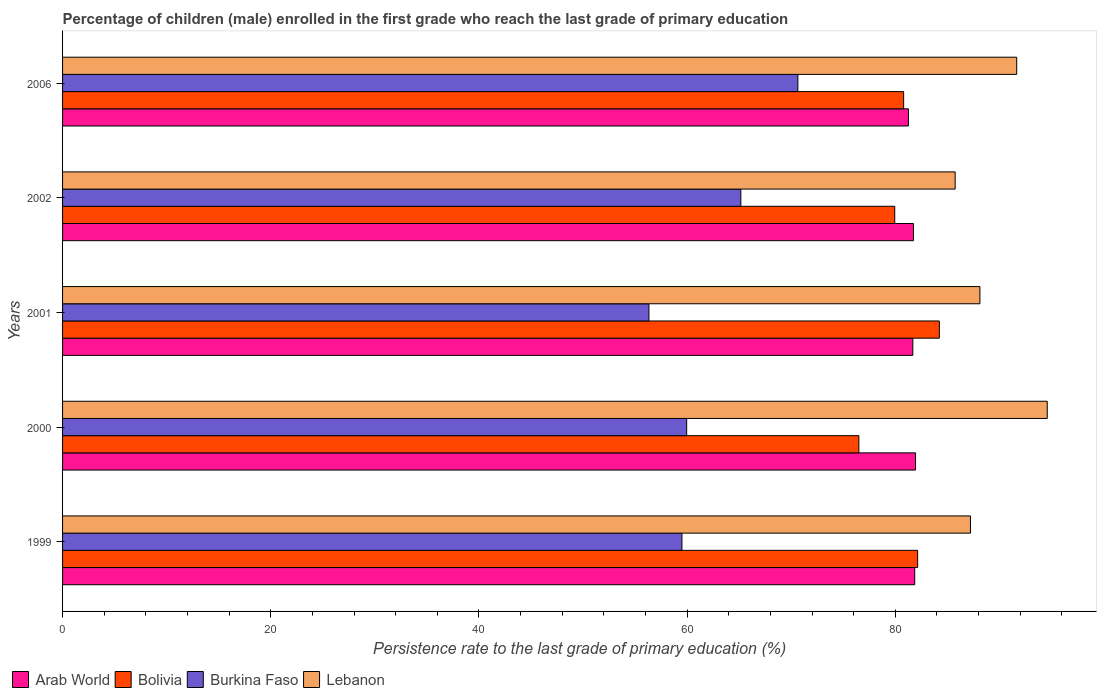Are the number of bars on each tick of the Y-axis equal?
Make the answer very short. Yes. How many bars are there on the 3rd tick from the bottom?
Provide a short and direct response. 4. What is the label of the 5th group of bars from the top?
Keep it short and to the point. 1999. What is the persistence rate of children in Burkina Faso in 2000?
Your answer should be very brief. 59.96. Across all years, what is the maximum persistence rate of children in Burkina Faso?
Your answer should be compact. 70.64. Across all years, what is the minimum persistence rate of children in Lebanon?
Your answer should be compact. 85.75. What is the total persistence rate of children in Burkina Faso in the graph?
Ensure brevity in your answer.  311.6. What is the difference between the persistence rate of children in Lebanon in 1999 and that in 2001?
Your answer should be compact. -0.91. What is the difference between the persistence rate of children in Lebanon in 2006 and the persistence rate of children in Arab World in 2002?
Provide a short and direct response. 9.92. What is the average persistence rate of children in Lebanon per year?
Keep it short and to the point. 89.47. In the year 2002, what is the difference between the persistence rate of children in Bolivia and persistence rate of children in Burkina Faso?
Your answer should be compact. 14.78. In how many years, is the persistence rate of children in Lebanon greater than 64 %?
Make the answer very short. 5. What is the ratio of the persistence rate of children in Arab World in 2001 to that in 2002?
Give a very brief answer. 1. What is the difference between the highest and the second highest persistence rate of children in Lebanon?
Provide a succinct answer. 2.94. What is the difference between the highest and the lowest persistence rate of children in Burkina Faso?
Provide a succinct answer. 14.31. Is it the case that in every year, the sum of the persistence rate of children in Burkina Faso and persistence rate of children in Arab World is greater than the sum of persistence rate of children in Bolivia and persistence rate of children in Lebanon?
Provide a succinct answer. Yes. What does the 2nd bar from the top in 2001 represents?
Offer a very short reply. Burkina Faso. What does the 3rd bar from the bottom in 2006 represents?
Give a very brief answer. Burkina Faso. How many bars are there?
Provide a succinct answer. 20. Are all the bars in the graph horizontal?
Ensure brevity in your answer.  Yes. Does the graph contain grids?
Offer a terse response. No. How many legend labels are there?
Offer a very short reply. 4. How are the legend labels stacked?
Make the answer very short. Horizontal. What is the title of the graph?
Your answer should be very brief. Percentage of children (male) enrolled in the first grade who reach the last grade of primary education. What is the label or title of the X-axis?
Provide a short and direct response. Persistence rate to the last grade of primary education (%). What is the label or title of the Y-axis?
Your answer should be very brief. Years. What is the Persistence rate to the last grade of primary education (%) in Arab World in 1999?
Provide a short and direct response. 81.87. What is the Persistence rate to the last grade of primary education (%) in Bolivia in 1999?
Provide a short and direct response. 82.15. What is the Persistence rate to the last grade of primary education (%) in Burkina Faso in 1999?
Give a very brief answer. 59.5. What is the Persistence rate to the last grade of primary education (%) of Lebanon in 1999?
Your answer should be compact. 87.22. What is the Persistence rate to the last grade of primary education (%) of Arab World in 2000?
Ensure brevity in your answer.  81.95. What is the Persistence rate to the last grade of primary education (%) in Bolivia in 2000?
Your response must be concise. 76.5. What is the Persistence rate to the last grade of primary education (%) in Burkina Faso in 2000?
Ensure brevity in your answer.  59.96. What is the Persistence rate to the last grade of primary education (%) in Lebanon in 2000?
Your answer should be very brief. 94.6. What is the Persistence rate to the last grade of primary education (%) in Arab World in 2001?
Keep it short and to the point. 81.68. What is the Persistence rate to the last grade of primary education (%) in Bolivia in 2001?
Provide a short and direct response. 84.23. What is the Persistence rate to the last grade of primary education (%) in Burkina Faso in 2001?
Provide a short and direct response. 56.33. What is the Persistence rate to the last grade of primary education (%) of Lebanon in 2001?
Offer a very short reply. 88.13. What is the Persistence rate to the last grade of primary education (%) of Arab World in 2002?
Offer a terse response. 81.75. What is the Persistence rate to the last grade of primary education (%) in Bolivia in 2002?
Provide a succinct answer. 79.95. What is the Persistence rate to the last grade of primary education (%) of Burkina Faso in 2002?
Offer a very short reply. 65.16. What is the Persistence rate to the last grade of primary education (%) of Lebanon in 2002?
Provide a succinct answer. 85.75. What is the Persistence rate to the last grade of primary education (%) in Arab World in 2006?
Keep it short and to the point. 81.26. What is the Persistence rate to the last grade of primary education (%) in Bolivia in 2006?
Ensure brevity in your answer.  80.8. What is the Persistence rate to the last grade of primary education (%) of Burkina Faso in 2006?
Provide a succinct answer. 70.64. What is the Persistence rate to the last grade of primary education (%) of Lebanon in 2006?
Your response must be concise. 91.66. Across all years, what is the maximum Persistence rate to the last grade of primary education (%) of Arab World?
Offer a very short reply. 81.95. Across all years, what is the maximum Persistence rate to the last grade of primary education (%) of Bolivia?
Ensure brevity in your answer.  84.23. Across all years, what is the maximum Persistence rate to the last grade of primary education (%) of Burkina Faso?
Provide a succinct answer. 70.64. Across all years, what is the maximum Persistence rate to the last grade of primary education (%) in Lebanon?
Make the answer very short. 94.6. Across all years, what is the minimum Persistence rate to the last grade of primary education (%) in Arab World?
Keep it short and to the point. 81.26. Across all years, what is the minimum Persistence rate to the last grade of primary education (%) of Bolivia?
Ensure brevity in your answer.  76.5. Across all years, what is the minimum Persistence rate to the last grade of primary education (%) in Burkina Faso?
Keep it short and to the point. 56.33. Across all years, what is the minimum Persistence rate to the last grade of primary education (%) of Lebanon?
Ensure brevity in your answer.  85.75. What is the total Persistence rate to the last grade of primary education (%) of Arab World in the graph?
Give a very brief answer. 408.51. What is the total Persistence rate to the last grade of primary education (%) in Bolivia in the graph?
Ensure brevity in your answer.  403.63. What is the total Persistence rate to the last grade of primary education (%) of Burkina Faso in the graph?
Give a very brief answer. 311.6. What is the total Persistence rate to the last grade of primary education (%) in Lebanon in the graph?
Your answer should be compact. 447.37. What is the difference between the Persistence rate to the last grade of primary education (%) in Arab World in 1999 and that in 2000?
Keep it short and to the point. -0.08. What is the difference between the Persistence rate to the last grade of primary education (%) in Bolivia in 1999 and that in 2000?
Keep it short and to the point. 5.65. What is the difference between the Persistence rate to the last grade of primary education (%) of Burkina Faso in 1999 and that in 2000?
Offer a very short reply. -0.45. What is the difference between the Persistence rate to the last grade of primary education (%) in Lebanon in 1999 and that in 2000?
Make the answer very short. -7.38. What is the difference between the Persistence rate to the last grade of primary education (%) of Arab World in 1999 and that in 2001?
Keep it short and to the point. 0.18. What is the difference between the Persistence rate to the last grade of primary education (%) in Bolivia in 1999 and that in 2001?
Your response must be concise. -2.09. What is the difference between the Persistence rate to the last grade of primary education (%) of Burkina Faso in 1999 and that in 2001?
Provide a short and direct response. 3.17. What is the difference between the Persistence rate to the last grade of primary education (%) of Lebanon in 1999 and that in 2001?
Your response must be concise. -0.91. What is the difference between the Persistence rate to the last grade of primary education (%) in Arab World in 1999 and that in 2002?
Give a very brief answer. 0.12. What is the difference between the Persistence rate to the last grade of primary education (%) in Bolivia in 1999 and that in 2002?
Your answer should be very brief. 2.2. What is the difference between the Persistence rate to the last grade of primary education (%) of Burkina Faso in 1999 and that in 2002?
Make the answer very short. -5.66. What is the difference between the Persistence rate to the last grade of primary education (%) of Lebanon in 1999 and that in 2002?
Your answer should be compact. 1.47. What is the difference between the Persistence rate to the last grade of primary education (%) in Arab World in 1999 and that in 2006?
Provide a succinct answer. 0.6. What is the difference between the Persistence rate to the last grade of primary education (%) of Bolivia in 1999 and that in 2006?
Provide a succinct answer. 1.34. What is the difference between the Persistence rate to the last grade of primary education (%) of Burkina Faso in 1999 and that in 2006?
Provide a succinct answer. -11.14. What is the difference between the Persistence rate to the last grade of primary education (%) in Lebanon in 1999 and that in 2006?
Provide a succinct answer. -4.44. What is the difference between the Persistence rate to the last grade of primary education (%) in Arab World in 2000 and that in 2001?
Offer a very short reply. 0.26. What is the difference between the Persistence rate to the last grade of primary education (%) of Bolivia in 2000 and that in 2001?
Your answer should be compact. -7.73. What is the difference between the Persistence rate to the last grade of primary education (%) in Burkina Faso in 2000 and that in 2001?
Offer a terse response. 3.63. What is the difference between the Persistence rate to the last grade of primary education (%) in Lebanon in 2000 and that in 2001?
Offer a terse response. 6.47. What is the difference between the Persistence rate to the last grade of primary education (%) of Arab World in 2000 and that in 2002?
Your answer should be compact. 0.2. What is the difference between the Persistence rate to the last grade of primary education (%) of Bolivia in 2000 and that in 2002?
Your answer should be very brief. -3.45. What is the difference between the Persistence rate to the last grade of primary education (%) of Burkina Faso in 2000 and that in 2002?
Offer a terse response. -5.21. What is the difference between the Persistence rate to the last grade of primary education (%) in Lebanon in 2000 and that in 2002?
Your answer should be compact. 8.85. What is the difference between the Persistence rate to the last grade of primary education (%) in Arab World in 2000 and that in 2006?
Offer a very short reply. 0.68. What is the difference between the Persistence rate to the last grade of primary education (%) of Bolivia in 2000 and that in 2006?
Give a very brief answer. -4.3. What is the difference between the Persistence rate to the last grade of primary education (%) in Burkina Faso in 2000 and that in 2006?
Your answer should be very brief. -10.69. What is the difference between the Persistence rate to the last grade of primary education (%) in Lebanon in 2000 and that in 2006?
Your answer should be very brief. 2.94. What is the difference between the Persistence rate to the last grade of primary education (%) in Arab World in 2001 and that in 2002?
Your answer should be compact. -0.06. What is the difference between the Persistence rate to the last grade of primary education (%) of Bolivia in 2001 and that in 2002?
Your response must be concise. 4.29. What is the difference between the Persistence rate to the last grade of primary education (%) in Burkina Faso in 2001 and that in 2002?
Your response must be concise. -8.83. What is the difference between the Persistence rate to the last grade of primary education (%) in Lebanon in 2001 and that in 2002?
Your answer should be very brief. 2.38. What is the difference between the Persistence rate to the last grade of primary education (%) of Arab World in 2001 and that in 2006?
Give a very brief answer. 0.42. What is the difference between the Persistence rate to the last grade of primary education (%) in Bolivia in 2001 and that in 2006?
Offer a terse response. 3.43. What is the difference between the Persistence rate to the last grade of primary education (%) of Burkina Faso in 2001 and that in 2006?
Your answer should be very brief. -14.31. What is the difference between the Persistence rate to the last grade of primary education (%) of Lebanon in 2001 and that in 2006?
Provide a short and direct response. -3.53. What is the difference between the Persistence rate to the last grade of primary education (%) in Arab World in 2002 and that in 2006?
Provide a succinct answer. 0.48. What is the difference between the Persistence rate to the last grade of primary education (%) in Bolivia in 2002 and that in 2006?
Your answer should be very brief. -0.85. What is the difference between the Persistence rate to the last grade of primary education (%) in Burkina Faso in 2002 and that in 2006?
Offer a terse response. -5.48. What is the difference between the Persistence rate to the last grade of primary education (%) of Lebanon in 2002 and that in 2006?
Ensure brevity in your answer.  -5.91. What is the difference between the Persistence rate to the last grade of primary education (%) in Arab World in 1999 and the Persistence rate to the last grade of primary education (%) in Bolivia in 2000?
Provide a short and direct response. 5.37. What is the difference between the Persistence rate to the last grade of primary education (%) of Arab World in 1999 and the Persistence rate to the last grade of primary education (%) of Burkina Faso in 2000?
Provide a succinct answer. 21.91. What is the difference between the Persistence rate to the last grade of primary education (%) of Arab World in 1999 and the Persistence rate to the last grade of primary education (%) of Lebanon in 2000?
Your answer should be very brief. -12.73. What is the difference between the Persistence rate to the last grade of primary education (%) in Bolivia in 1999 and the Persistence rate to the last grade of primary education (%) in Burkina Faso in 2000?
Provide a short and direct response. 22.19. What is the difference between the Persistence rate to the last grade of primary education (%) in Bolivia in 1999 and the Persistence rate to the last grade of primary education (%) in Lebanon in 2000?
Provide a succinct answer. -12.45. What is the difference between the Persistence rate to the last grade of primary education (%) of Burkina Faso in 1999 and the Persistence rate to the last grade of primary education (%) of Lebanon in 2000?
Your answer should be very brief. -35.1. What is the difference between the Persistence rate to the last grade of primary education (%) in Arab World in 1999 and the Persistence rate to the last grade of primary education (%) in Bolivia in 2001?
Give a very brief answer. -2.37. What is the difference between the Persistence rate to the last grade of primary education (%) in Arab World in 1999 and the Persistence rate to the last grade of primary education (%) in Burkina Faso in 2001?
Offer a very short reply. 25.53. What is the difference between the Persistence rate to the last grade of primary education (%) of Arab World in 1999 and the Persistence rate to the last grade of primary education (%) of Lebanon in 2001?
Give a very brief answer. -6.26. What is the difference between the Persistence rate to the last grade of primary education (%) of Bolivia in 1999 and the Persistence rate to the last grade of primary education (%) of Burkina Faso in 2001?
Your answer should be compact. 25.81. What is the difference between the Persistence rate to the last grade of primary education (%) in Bolivia in 1999 and the Persistence rate to the last grade of primary education (%) in Lebanon in 2001?
Your answer should be very brief. -5.98. What is the difference between the Persistence rate to the last grade of primary education (%) of Burkina Faso in 1999 and the Persistence rate to the last grade of primary education (%) of Lebanon in 2001?
Provide a succinct answer. -28.63. What is the difference between the Persistence rate to the last grade of primary education (%) of Arab World in 1999 and the Persistence rate to the last grade of primary education (%) of Bolivia in 2002?
Provide a short and direct response. 1.92. What is the difference between the Persistence rate to the last grade of primary education (%) in Arab World in 1999 and the Persistence rate to the last grade of primary education (%) in Burkina Faso in 2002?
Offer a very short reply. 16.7. What is the difference between the Persistence rate to the last grade of primary education (%) in Arab World in 1999 and the Persistence rate to the last grade of primary education (%) in Lebanon in 2002?
Offer a terse response. -3.89. What is the difference between the Persistence rate to the last grade of primary education (%) in Bolivia in 1999 and the Persistence rate to the last grade of primary education (%) in Burkina Faso in 2002?
Give a very brief answer. 16.98. What is the difference between the Persistence rate to the last grade of primary education (%) in Bolivia in 1999 and the Persistence rate to the last grade of primary education (%) in Lebanon in 2002?
Your answer should be very brief. -3.61. What is the difference between the Persistence rate to the last grade of primary education (%) of Burkina Faso in 1999 and the Persistence rate to the last grade of primary education (%) of Lebanon in 2002?
Provide a succinct answer. -26.25. What is the difference between the Persistence rate to the last grade of primary education (%) of Arab World in 1999 and the Persistence rate to the last grade of primary education (%) of Bolivia in 2006?
Give a very brief answer. 1.06. What is the difference between the Persistence rate to the last grade of primary education (%) in Arab World in 1999 and the Persistence rate to the last grade of primary education (%) in Burkina Faso in 2006?
Your answer should be compact. 11.22. What is the difference between the Persistence rate to the last grade of primary education (%) in Arab World in 1999 and the Persistence rate to the last grade of primary education (%) in Lebanon in 2006?
Offer a very short reply. -9.8. What is the difference between the Persistence rate to the last grade of primary education (%) of Bolivia in 1999 and the Persistence rate to the last grade of primary education (%) of Burkina Faso in 2006?
Your answer should be compact. 11.5. What is the difference between the Persistence rate to the last grade of primary education (%) of Bolivia in 1999 and the Persistence rate to the last grade of primary education (%) of Lebanon in 2006?
Offer a very short reply. -9.52. What is the difference between the Persistence rate to the last grade of primary education (%) in Burkina Faso in 1999 and the Persistence rate to the last grade of primary education (%) in Lebanon in 2006?
Make the answer very short. -32.16. What is the difference between the Persistence rate to the last grade of primary education (%) in Arab World in 2000 and the Persistence rate to the last grade of primary education (%) in Bolivia in 2001?
Make the answer very short. -2.29. What is the difference between the Persistence rate to the last grade of primary education (%) of Arab World in 2000 and the Persistence rate to the last grade of primary education (%) of Burkina Faso in 2001?
Your answer should be compact. 25.62. What is the difference between the Persistence rate to the last grade of primary education (%) in Arab World in 2000 and the Persistence rate to the last grade of primary education (%) in Lebanon in 2001?
Provide a short and direct response. -6.18. What is the difference between the Persistence rate to the last grade of primary education (%) of Bolivia in 2000 and the Persistence rate to the last grade of primary education (%) of Burkina Faso in 2001?
Ensure brevity in your answer.  20.17. What is the difference between the Persistence rate to the last grade of primary education (%) of Bolivia in 2000 and the Persistence rate to the last grade of primary education (%) of Lebanon in 2001?
Your answer should be very brief. -11.63. What is the difference between the Persistence rate to the last grade of primary education (%) of Burkina Faso in 2000 and the Persistence rate to the last grade of primary education (%) of Lebanon in 2001?
Give a very brief answer. -28.17. What is the difference between the Persistence rate to the last grade of primary education (%) of Arab World in 2000 and the Persistence rate to the last grade of primary education (%) of Bolivia in 2002?
Make the answer very short. 2. What is the difference between the Persistence rate to the last grade of primary education (%) in Arab World in 2000 and the Persistence rate to the last grade of primary education (%) in Burkina Faso in 2002?
Offer a terse response. 16.78. What is the difference between the Persistence rate to the last grade of primary education (%) in Arab World in 2000 and the Persistence rate to the last grade of primary education (%) in Lebanon in 2002?
Give a very brief answer. -3.81. What is the difference between the Persistence rate to the last grade of primary education (%) in Bolivia in 2000 and the Persistence rate to the last grade of primary education (%) in Burkina Faso in 2002?
Make the answer very short. 11.34. What is the difference between the Persistence rate to the last grade of primary education (%) of Bolivia in 2000 and the Persistence rate to the last grade of primary education (%) of Lebanon in 2002?
Your response must be concise. -9.25. What is the difference between the Persistence rate to the last grade of primary education (%) in Burkina Faso in 2000 and the Persistence rate to the last grade of primary education (%) in Lebanon in 2002?
Your response must be concise. -25.8. What is the difference between the Persistence rate to the last grade of primary education (%) in Arab World in 2000 and the Persistence rate to the last grade of primary education (%) in Bolivia in 2006?
Your response must be concise. 1.14. What is the difference between the Persistence rate to the last grade of primary education (%) of Arab World in 2000 and the Persistence rate to the last grade of primary education (%) of Burkina Faso in 2006?
Your answer should be compact. 11.3. What is the difference between the Persistence rate to the last grade of primary education (%) in Arab World in 2000 and the Persistence rate to the last grade of primary education (%) in Lebanon in 2006?
Offer a terse response. -9.72. What is the difference between the Persistence rate to the last grade of primary education (%) of Bolivia in 2000 and the Persistence rate to the last grade of primary education (%) of Burkina Faso in 2006?
Keep it short and to the point. 5.86. What is the difference between the Persistence rate to the last grade of primary education (%) of Bolivia in 2000 and the Persistence rate to the last grade of primary education (%) of Lebanon in 2006?
Give a very brief answer. -15.16. What is the difference between the Persistence rate to the last grade of primary education (%) in Burkina Faso in 2000 and the Persistence rate to the last grade of primary education (%) in Lebanon in 2006?
Ensure brevity in your answer.  -31.71. What is the difference between the Persistence rate to the last grade of primary education (%) of Arab World in 2001 and the Persistence rate to the last grade of primary education (%) of Bolivia in 2002?
Offer a very short reply. 1.74. What is the difference between the Persistence rate to the last grade of primary education (%) of Arab World in 2001 and the Persistence rate to the last grade of primary education (%) of Burkina Faso in 2002?
Ensure brevity in your answer.  16.52. What is the difference between the Persistence rate to the last grade of primary education (%) in Arab World in 2001 and the Persistence rate to the last grade of primary education (%) in Lebanon in 2002?
Your answer should be very brief. -4.07. What is the difference between the Persistence rate to the last grade of primary education (%) of Bolivia in 2001 and the Persistence rate to the last grade of primary education (%) of Burkina Faso in 2002?
Offer a very short reply. 19.07. What is the difference between the Persistence rate to the last grade of primary education (%) of Bolivia in 2001 and the Persistence rate to the last grade of primary education (%) of Lebanon in 2002?
Make the answer very short. -1.52. What is the difference between the Persistence rate to the last grade of primary education (%) in Burkina Faso in 2001 and the Persistence rate to the last grade of primary education (%) in Lebanon in 2002?
Offer a terse response. -29.42. What is the difference between the Persistence rate to the last grade of primary education (%) in Arab World in 2001 and the Persistence rate to the last grade of primary education (%) in Bolivia in 2006?
Provide a short and direct response. 0.88. What is the difference between the Persistence rate to the last grade of primary education (%) in Arab World in 2001 and the Persistence rate to the last grade of primary education (%) in Burkina Faso in 2006?
Provide a succinct answer. 11.04. What is the difference between the Persistence rate to the last grade of primary education (%) of Arab World in 2001 and the Persistence rate to the last grade of primary education (%) of Lebanon in 2006?
Your response must be concise. -9.98. What is the difference between the Persistence rate to the last grade of primary education (%) of Bolivia in 2001 and the Persistence rate to the last grade of primary education (%) of Burkina Faso in 2006?
Your answer should be very brief. 13.59. What is the difference between the Persistence rate to the last grade of primary education (%) in Bolivia in 2001 and the Persistence rate to the last grade of primary education (%) in Lebanon in 2006?
Provide a succinct answer. -7.43. What is the difference between the Persistence rate to the last grade of primary education (%) of Burkina Faso in 2001 and the Persistence rate to the last grade of primary education (%) of Lebanon in 2006?
Ensure brevity in your answer.  -35.33. What is the difference between the Persistence rate to the last grade of primary education (%) of Arab World in 2002 and the Persistence rate to the last grade of primary education (%) of Bolivia in 2006?
Your answer should be very brief. 0.95. What is the difference between the Persistence rate to the last grade of primary education (%) of Arab World in 2002 and the Persistence rate to the last grade of primary education (%) of Burkina Faso in 2006?
Provide a succinct answer. 11.1. What is the difference between the Persistence rate to the last grade of primary education (%) in Arab World in 2002 and the Persistence rate to the last grade of primary education (%) in Lebanon in 2006?
Your answer should be very brief. -9.92. What is the difference between the Persistence rate to the last grade of primary education (%) in Bolivia in 2002 and the Persistence rate to the last grade of primary education (%) in Burkina Faso in 2006?
Your response must be concise. 9.3. What is the difference between the Persistence rate to the last grade of primary education (%) in Bolivia in 2002 and the Persistence rate to the last grade of primary education (%) in Lebanon in 2006?
Your answer should be compact. -11.72. What is the difference between the Persistence rate to the last grade of primary education (%) in Burkina Faso in 2002 and the Persistence rate to the last grade of primary education (%) in Lebanon in 2006?
Your answer should be very brief. -26.5. What is the average Persistence rate to the last grade of primary education (%) in Arab World per year?
Your answer should be compact. 81.7. What is the average Persistence rate to the last grade of primary education (%) in Bolivia per year?
Provide a succinct answer. 80.73. What is the average Persistence rate to the last grade of primary education (%) in Burkina Faso per year?
Your response must be concise. 62.32. What is the average Persistence rate to the last grade of primary education (%) of Lebanon per year?
Your answer should be compact. 89.47. In the year 1999, what is the difference between the Persistence rate to the last grade of primary education (%) of Arab World and Persistence rate to the last grade of primary education (%) of Bolivia?
Provide a succinct answer. -0.28. In the year 1999, what is the difference between the Persistence rate to the last grade of primary education (%) of Arab World and Persistence rate to the last grade of primary education (%) of Burkina Faso?
Your response must be concise. 22.36. In the year 1999, what is the difference between the Persistence rate to the last grade of primary education (%) of Arab World and Persistence rate to the last grade of primary education (%) of Lebanon?
Your answer should be very brief. -5.36. In the year 1999, what is the difference between the Persistence rate to the last grade of primary education (%) of Bolivia and Persistence rate to the last grade of primary education (%) of Burkina Faso?
Keep it short and to the point. 22.64. In the year 1999, what is the difference between the Persistence rate to the last grade of primary education (%) of Bolivia and Persistence rate to the last grade of primary education (%) of Lebanon?
Keep it short and to the point. -5.08. In the year 1999, what is the difference between the Persistence rate to the last grade of primary education (%) in Burkina Faso and Persistence rate to the last grade of primary education (%) in Lebanon?
Provide a short and direct response. -27.72. In the year 2000, what is the difference between the Persistence rate to the last grade of primary education (%) of Arab World and Persistence rate to the last grade of primary education (%) of Bolivia?
Keep it short and to the point. 5.45. In the year 2000, what is the difference between the Persistence rate to the last grade of primary education (%) in Arab World and Persistence rate to the last grade of primary education (%) in Burkina Faso?
Offer a very short reply. 21.99. In the year 2000, what is the difference between the Persistence rate to the last grade of primary education (%) in Arab World and Persistence rate to the last grade of primary education (%) in Lebanon?
Your answer should be very brief. -12.65. In the year 2000, what is the difference between the Persistence rate to the last grade of primary education (%) of Bolivia and Persistence rate to the last grade of primary education (%) of Burkina Faso?
Provide a short and direct response. 16.54. In the year 2000, what is the difference between the Persistence rate to the last grade of primary education (%) in Bolivia and Persistence rate to the last grade of primary education (%) in Lebanon?
Make the answer very short. -18.1. In the year 2000, what is the difference between the Persistence rate to the last grade of primary education (%) in Burkina Faso and Persistence rate to the last grade of primary education (%) in Lebanon?
Your answer should be very brief. -34.64. In the year 2001, what is the difference between the Persistence rate to the last grade of primary education (%) of Arab World and Persistence rate to the last grade of primary education (%) of Bolivia?
Your answer should be very brief. -2.55. In the year 2001, what is the difference between the Persistence rate to the last grade of primary education (%) in Arab World and Persistence rate to the last grade of primary education (%) in Burkina Faso?
Provide a short and direct response. 25.35. In the year 2001, what is the difference between the Persistence rate to the last grade of primary education (%) of Arab World and Persistence rate to the last grade of primary education (%) of Lebanon?
Provide a succinct answer. -6.45. In the year 2001, what is the difference between the Persistence rate to the last grade of primary education (%) of Bolivia and Persistence rate to the last grade of primary education (%) of Burkina Faso?
Your answer should be very brief. 27.9. In the year 2001, what is the difference between the Persistence rate to the last grade of primary education (%) in Bolivia and Persistence rate to the last grade of primary education (%) in Lebanon?
Offer a terse response. -3.9. In the year 2001, what is the difference between the Persistence rate to the last grade of primary education (%) of Burkina Faso and Persistence rate to the last grade of primary education (%) of Lebanon?
Ensure brevity in your answer.  -31.8. In the year 2002, what is the difference between the Persistence rate to the last grade of primary education (%) of Arab World and Persistence rate to the last grade of primary education (%) of Bolivia?
Keep it short and to the point. 1.8. In the year 2002, what is the difference between the Persistence rate to the last grade of primary education (%) in Arab World and Persistence rate to the last grade of primary education (%) in Burkina Faso?
Your answer should be very brief. 16.58. In the year 2002, what is the difference between the Persistence rate to the last grade of primary education (%) of Arab World and Persistence rate to the last grade of primary education (%) of Lebanon?
Ensure brevity in your answer.  -4.01. In the year 2002, what is the difference between the Persistence rate to the last grade of primary education (%) of Bolivia and Persistence rate to the last grade of primary education (%) of Burkina Faso?
Offer a terse response. 14.78. In the year 2002, what is the difference between the Persistence rate to the last grade of primary education (%) in Bolivia and Persistence rate to the last grade of primary education (%) in Lebanon?
Offer a terse response. -5.81. In the year 2002, what is the difference between the Persistence rate to the last grade of primary education (%) of Burkina Faso and Persistence rate to the last grade of primary education (%) of Lebanon?
Give a very brief answer. -20.59. In the year 2006, what is the difference between the Persistence rate to the last grade of primary education (%) of Arab World and Persistence rate to the last grade of primary education (%) of Bolivia?
Offer a terse response. 0.46. In the year 2006, what is the difference between the Persistence rate to the last grade of primary education (%) in Arab World and Persistence rate to the last grade of primary education (%) in Burkina Faso?
Offer a terse response. 10.62. In the year 2006, what is the difference between the Persistence rate to the last grade of primary education (%) of Arab World and Persistence rate to the last grade of primary education (%) of Lebanon?
Provide a succinct answer. -10.4. In the year 2006, what is the difference between the Persistence rate to the last grade of primary education (%) in Bolivia and Persistence rate to the last grade of primary education (%) in Burkina Faso?
Offer a terse response. 10.16. In the year 2006, what is the difference between the Persistence rate to the last grade of primary education (%) in Bolivia and Persistence rate to the last grade of primary education (%) in Lebanon?
Ensure brevity in your answer.  -10.86. In the year 2006, what is the difference between the Persistence rate to the last grade of primary education (%) in Burkina Faso and Persistence rate to the last grade of primary education (%) in Lebanon?
Provide a succinct answer. -21.02. What is the ratio of the Persistence rate to the last grade of primary education (%) of Bolivia in 1999 to that in 2000?
Offer a terse response. 1.07. What is the ratio of the Persistence rate to the last grade of primary education (%) of Burkina Faso in 1999 to that in 2000?
Offer a terse response. 0.99. What is the ratio of the Persistence rate to the last grade of primary education (%) in Lebanon in 1999 to that in 2000?
Give a very brief answer. 0.92. What is the ratio of the Persistence rate to the last grade of primary education (%) of Arab World in 1999 to that in 2001?
Provide a succinct answer. 1. What is the ratio of the Persistence rate to the last grade of primary education (%) of Bolivia in 1999 to that in 2001?
Ensure brevity in your answer.  0.98. What is the ratio of the Persistence rate to the last grade of primary education (%) in Burkina Faso in 1999 to that in 2001?
Provide a short and direct response. 1.06. What is the ratio of the Persistence rate to the last grade of primary education (%) in Lebanon in 1999 to that in 2001?
Keep it short and to the point. 0.99. What is the ratio of the Persistence rate to the last grade of primary education (%) in Arab World in 1999 to that in 2002?
Ensure brevity in your answer.  1. What is the ratio of the Persistence rate to the last grade of primary education (%) in Bolivia in 1999 to that in 2002?
Make the answer very short. 1.03. What is the ratio of the Persistence rate to the last grade of primary education (%) of Burkina Faso in 1999 to that in 2002?
Keep it short and to the point. 0.91. What is the ratio of the Persistence rate to the last grade of primary education (%) in Lebanon in 1999 to that in 2002?
Your response must be concise. 1.02. What is the ratio of the Persistence rate to the last grade of primary education (%) of Arab World in 1999 to that in 2006?
Provide a succinct answer. 1.01. What is the ratio of the Persistence rate to the last grade of primary education (%) of Bolivia in 1999 to that in 2006?
Provide a short and direct response. 1.02. What is the ratio of the Persistence rate to the last grade of primary education (%) in Burkina Faso in 1999 to that in 2006?
Provide a succinct answer. 0.84. What is the ratio of the Persistence rate to the last grade of primary education (%) in Lebanon in 1999 to that in 2006?
Offer a very short reply. 0.95. What is the ratio of the Persistence rate to the last grade of primary education (%) of Bolivia in 2000 to that in 2001?
Offer a terse response. 0.91. What is the ratio of the Persistence rate to the last grade of primary education (%) in Burkina Faso in 2000 to that in 2001?
Provide a succinct answer. 1.06. What is the ratio of the Persistence rate to the last grade of primary education (%) in Lebanon in 2000 to that in 2001?
Provide a short and direct response. 1.07. What is the ratio of the Persistence rate to the last grade of primary education (%) of Bolivia in 2000 to that in 2002?
Make the answer very short. 0.96. What is the ratio of the Persistence rate to the last grade of primary education (%) of Burkina Faso in 2000 to that in 2002?
Make the answer very short. 0.92. What is the ratio of the Persistence rate to the last grade of primary education (%) in Lebanon in 2000 to that in 2002?
Offer a terse response. 1.1. What is the ratio of the Persistence rate to the last grade of primary education (%) of Arab World in 2000 to that in 2006?
Provide a short and direct response. 1.01. What is the ratio of the Persistence rate to the last grade of primary education (%) of Bolivia in 2000 to that in 2006?
Give a very brief answer. 0.95. What is the ratio of the Persistence rate to the last grade of primary education (%) of Burkina Faso in 2000 to that in 2006?
Your response must be concise. 0.85. What is the ratio of the Persistence rate to the last grade of primary education (%) in Lebanon in 2000 to that in 2006?
Make the answer very short. 1.03. What is the ratio of the Persistence rate to the last grade of primary education (%) of Arab World in 2001 to that in 2002?
Provide a succinct answer. 1. What is the ratio of the Persistence rate to the last grade of primary education (%) in Bolivia in 2001 to that in 2002?
Provide a succinct answer. 1.05. What is the ratio of the Persistence rate to the last grade of primary education (%) in Burkina Faso in 2001 to that in 2002?
Your answer should be compact. 0.86. What is the ratio of the Persistence rate to the last grade of primary education (%) in Lebanon in 2001 to that in 2002?
Your response must be concise. 1.03. What is the ratio of the Persistence rate to the last grade of primary education (%) in Bolivia in 2001 to that in 2006?
Give a very brief answer. 1.04. What is the ratio of the Persistence rate to the last grade of primary education (%) in Burkina Faso in 2001 to that in 2006?
Your response must be concise. 0.8. What is the ratio of the Persistence rate to the last grade of primary education (%) of Lebanon in 2001 to that in 2006?
Keep it short and to the point. 0.96. What is the ratio of the Persistence rate to the last grade of primary education (%) of Arab World in 2002 to that in 2006?
Offer a very short reply. 1.01. What is the ratio of the Persistence rate to the last grade of primary education (%) of Bolivia in 2002 to that in 2006?
Offer a very short reply. 0.99. What is the ratio of the Persistence rate to the last grade of primary education (%) in Burkina Faso in 2002 to that in 2006?
Keep it short and to the point. 0.92. What is the ratio of the Persistence rate to the last grade of primary education (%) in Lebanon in 2002 to that in 2006?
Your answer should be very brief. 0.94. What is the difference between the highest and the second highest Persistence rate to the last grade of primary education (%) in Arab World?
Your response must be concise. 0.08. What is the difference between the highest and the second highest Persistence rate to the last grade of primary education (%) in Bolivia?
Your answer should be very brief. 2.09. What is the difference between the highest and the second highest Persistence rate to the last grade of primary education (%) in Burkina Faso?
Offer a terse response. 5.48. What is the difference between the highest and the second highest Persistence rate to the last grade of primary education (%) in Lebanon?
Your response must be concise. 2.94. What is the difference between the highest and the lowest Persistence rate to the last grade of primary education (%) of Arab World?
Your response must be concise. 0.68. What is the difference between the highest and the lowest Persistence rate to the last grade of primary education (%) of Bolivia?
Provide a succinct answer. 7.73. What is the difference between the highest and the lowest Persistence rate to the last grade of primary education (%) in Burkina Faso?
Offer a terse response. 14.31. What is the difference between the highest and the lowest Persistence rate to the last grade of primary education (%) in Lebanon?
Your answer should be compact. 8.85. 